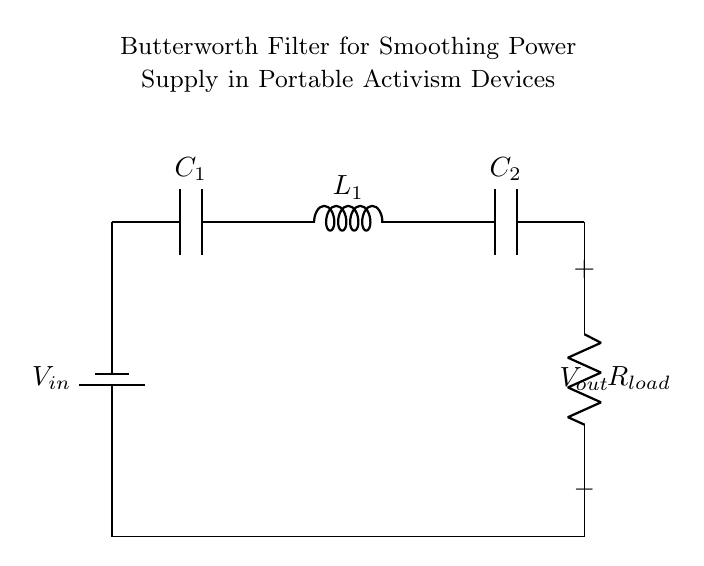What is the input voltage of the circuit? The input voltage is labeled as V_in, which indicates the voltage supplied to the circuit.
Answer: V_in What components are used in this Butterworth filter? The circuit diagram includes a battery, two capacitors, one inductor, and a load resistor, all of which are typical components for this type of filter.
Answer: Battery, capacitors, inductor, load resistor What is the function of the capacitors in this circuit? The capacitors are used to store and smooth out fluctuations in voltage, helping to create a more stable output voltage by filtering out noise from the input source.
Answer: Smoothing voltage fluctuations What is the output voltage of the circuit? The output voltage is labeled as V_out in the diagram, which is the voltage across the load resistor after filtering.
Answer: V_out How many capacitors are present in this circuit? The diagram shows two capacitors, one labeled C_1 at the input and the other labeled C_2 at the output.
Answer: Two Why is this circuit designed as a Butterworth filter? A Butterworth filter is designed to provide a flat frequency response and minimal distortion in the passband, making it ideal for smoothing out voltage fluctuations in portable electronic devices.
Answer: To minimize distortion Where is the load resistor located in the circuit? The load resistor is positioned at the end of the circuit, connected to the output capacitor, and serves as the component that uses the filtered voltage output.
Answer: At the output 